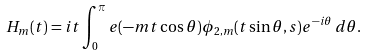<formula> <loc_0><loc_0><loc_500><loc_500>H _ { m } ( t ) = i t \int _ { 0 } ^ { \pi } e ( - m t \cos \theta ) \phi _ { 2 , m } ( t \sin \theta , s ) e ^ { - i \theta } \, d \theta .</formula> 